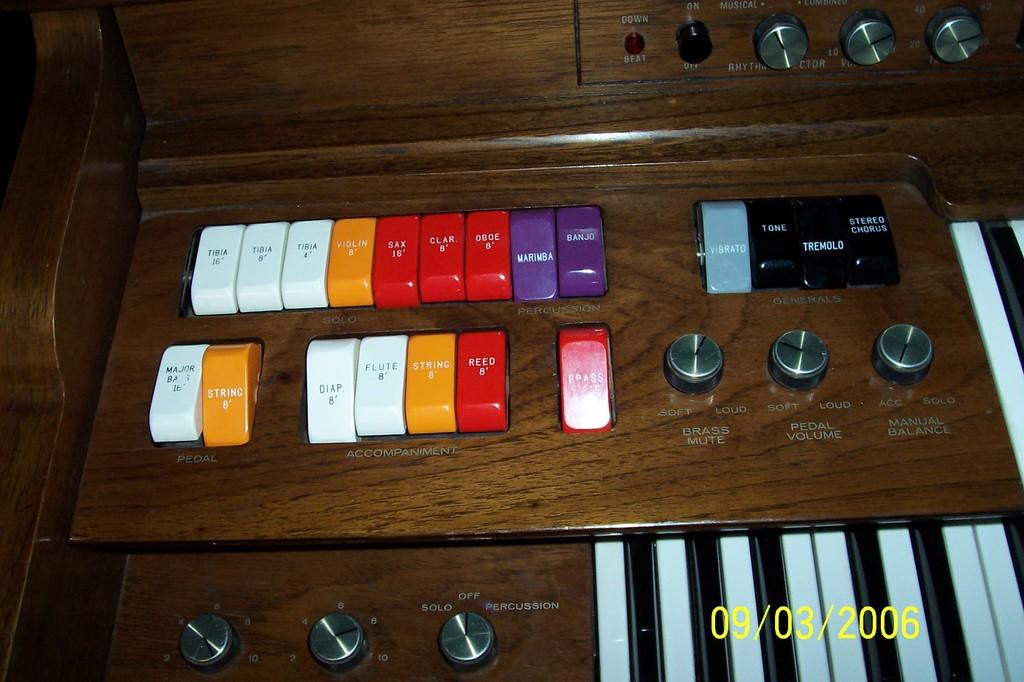What type of device is shown in the image? The image contains a keyboard. What are the primary components of the keyboard? There are keys, rotators, switches, and LED lights visible on the keyboard. How many birds are perched on the faucet in the image? There are no birds or faucets present in the image; it features a keyboard with various components. 